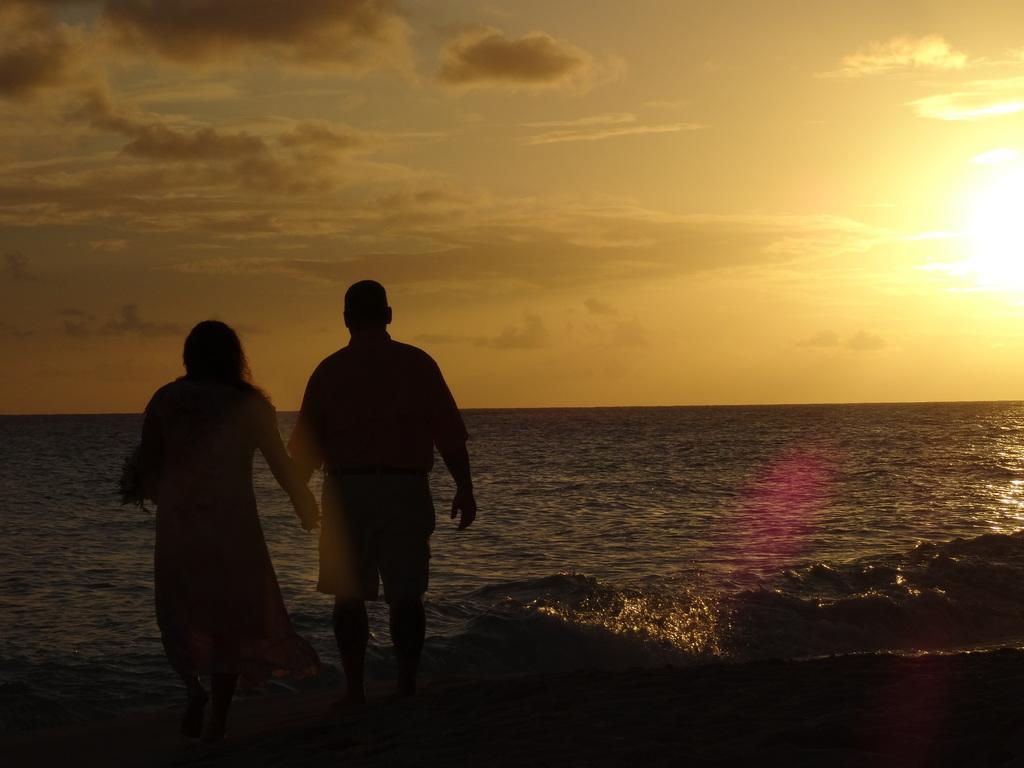How would you summarize this image in a sentence or two? In this age we can see man and a woman. In the back there is water. In the background there is sky with clouds. 